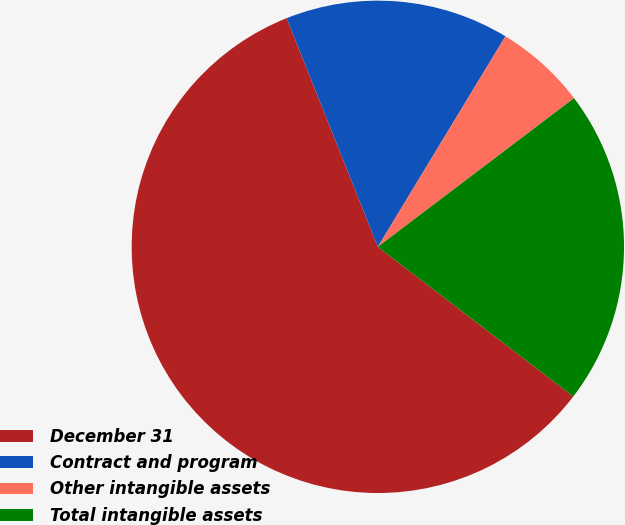<chart> <loc_0><loc_0><loc_500><loc_500><pie_chart><fcel>December 31<fcel>Contract and program<fcel>Other intangible assets<fcel>Total intangible assets<nl><fcel>58.56%<fcel>14.71%<fcel>6.01%<fcel>20.72%<nl></chart> 